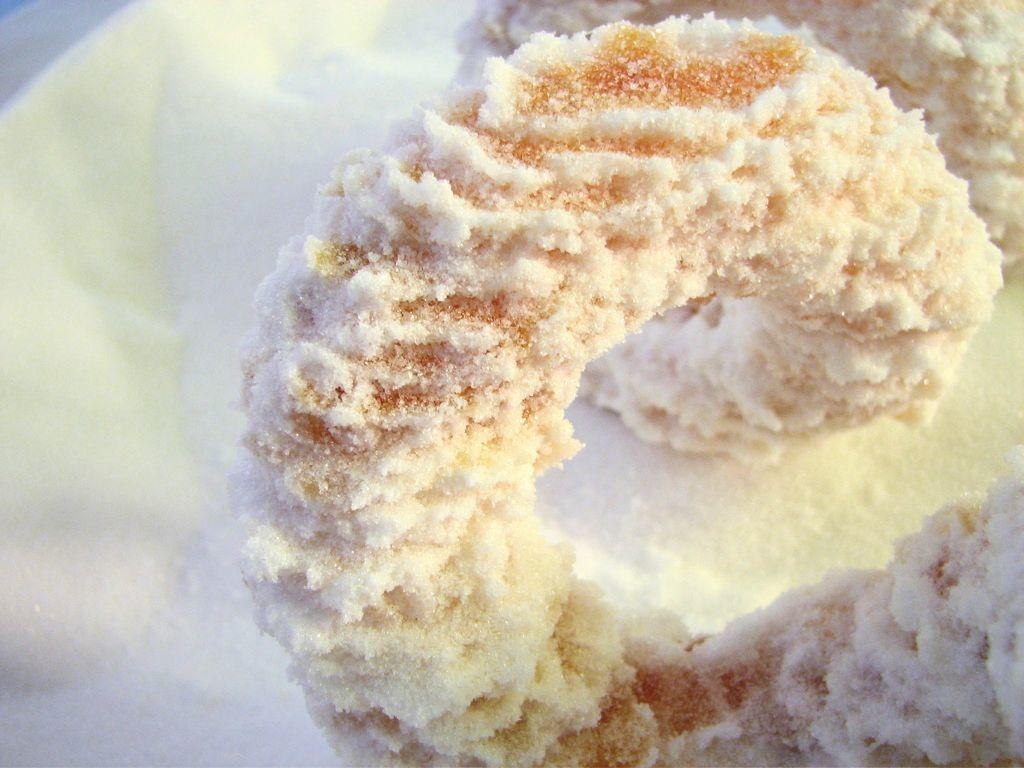What is the main subject of the image? There is a food item in the image. How is the food item prepared or served? The food item has dressing on it. What is the color of the food item and its dressing? The food item and its dressing are of white color. Is there a volcano erupting in the image? No, there is no volcano or any indication of destruction present in the image. Can you tell me how many parcels are visible in the image? There is no parcel present in the image. 